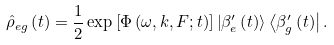Convert formula to latex. <formula><loc_0><loc_0><loc_500><loc_500>\hat { \rho } _ { e g } \left ( t \right ) = \frac { 1 } { 2 } \exp \left [ \Phi \left ( \omega , k , F ; t \right ) \right ] \left | \beta _ { e } ^ { \prime } \left ( t \right ) \right \rangle \left \langle \beta _ { g } ^ { \prime } \left ( t \right ) \right | .</formula> 